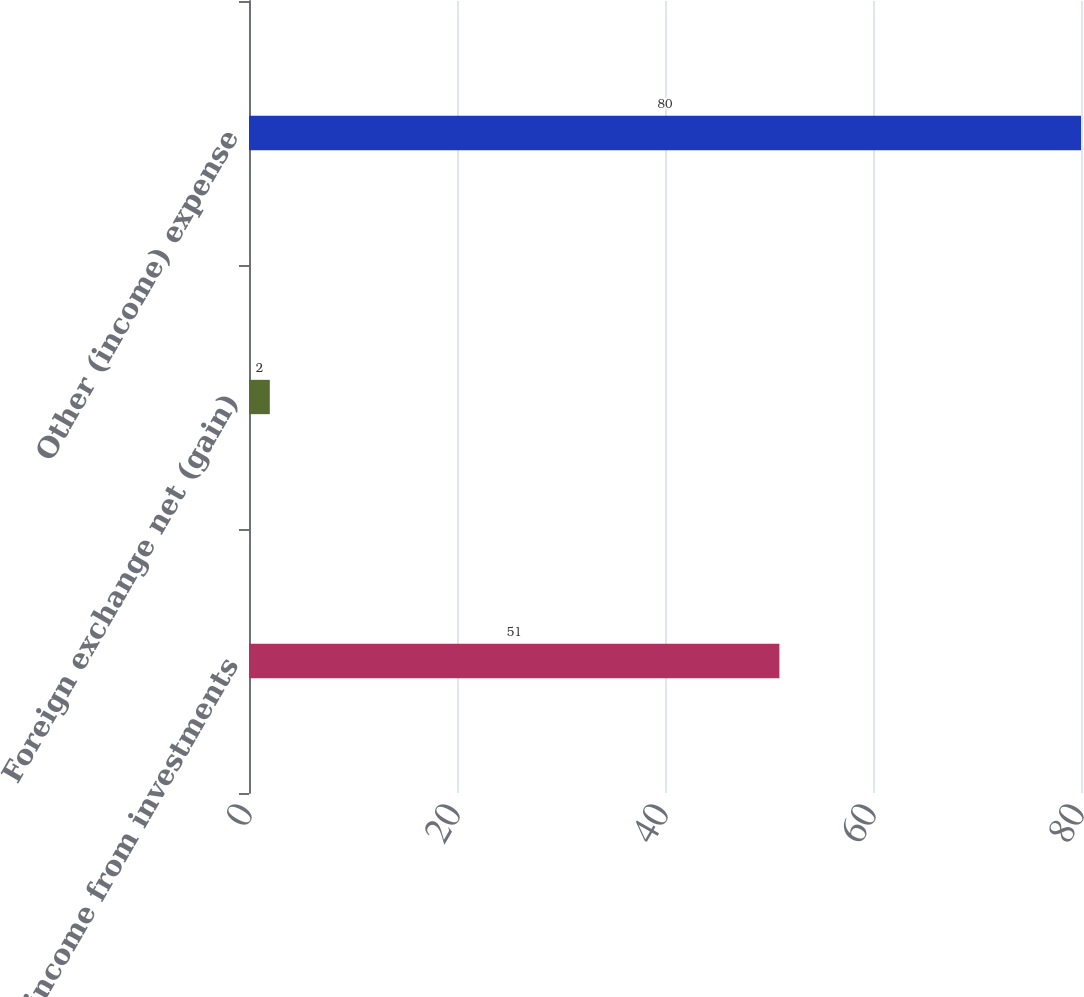Convert chart. <chart><loc_0><loc_0><loc_500><loc_500><bar_chart><fcel>Equity income from investments<fcel>Foreign exchange net (gain)<fcel>Other (income) expense<nl><fcel>51<fcel>2<fcel>80<nl></chart> 